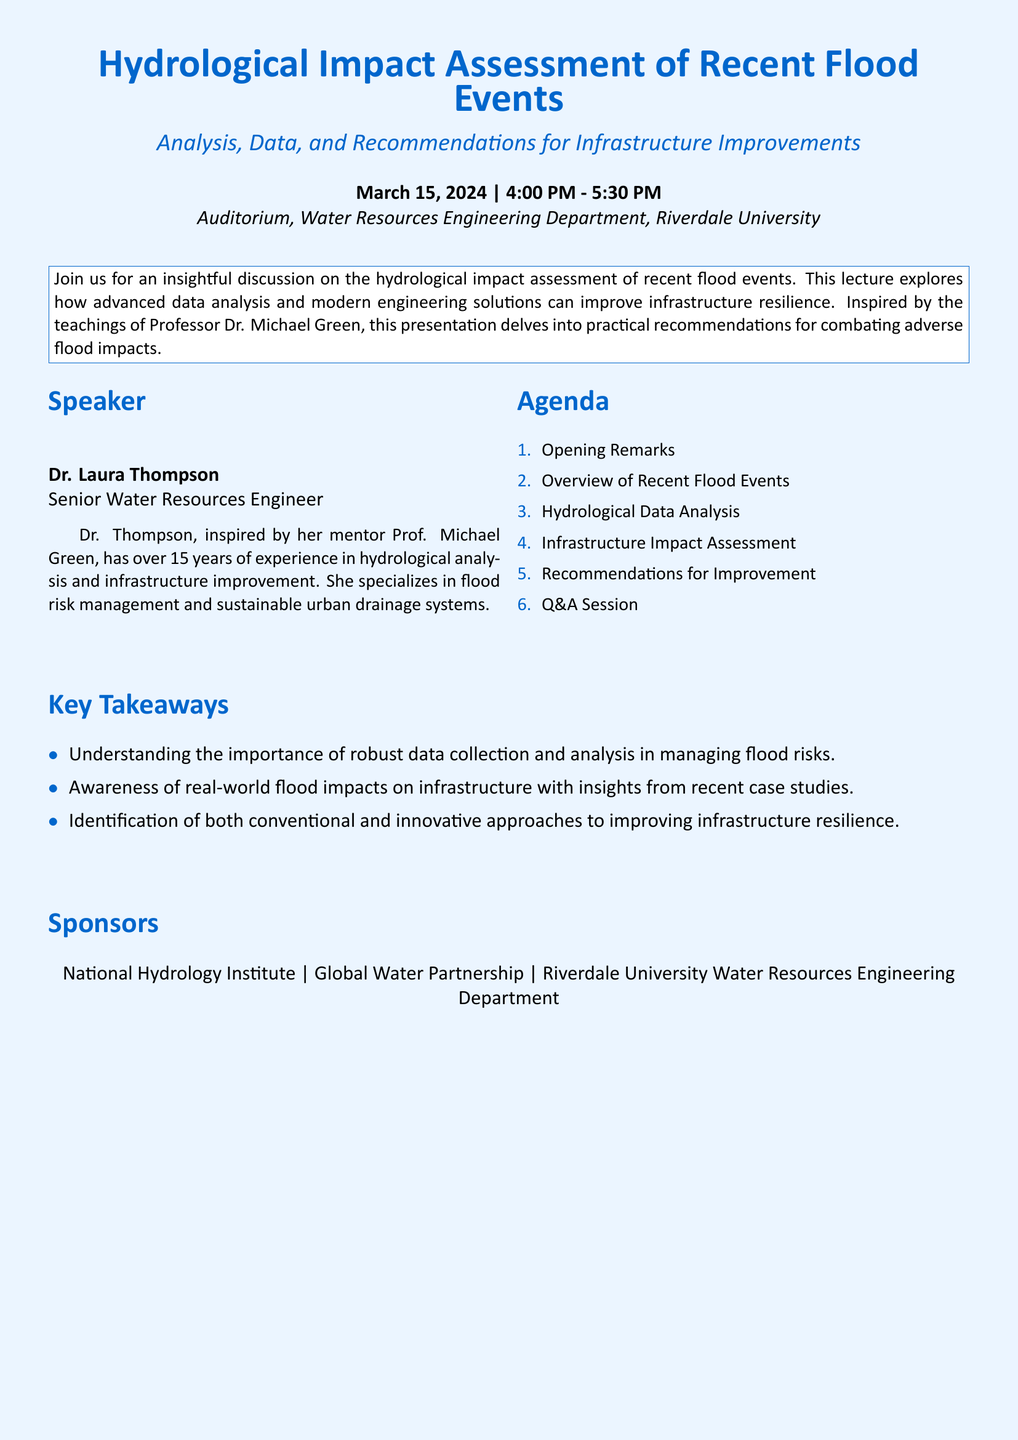What is the title of the event? The title of the event is presented at the top of the document under the name of the playbill.
Answer: Hydrological Impact Assessment of Recent Flood Events Who is the speaker of the event? The speaker's name is listed in the "Speaker" section of the document.
Answer: Dr. Laura Thompson What is the main focus of the lecture? The focus of the lecture is summarized in the description box at the beginning of the document.
Answer: Hydrological impact assessment of recent flood events How many years of experience does Dr. Laura Thompson have? The document states her experience in the speaker's biography.
Answer: 15 years What is one of the key takeaways from the event? Key takeaways are listed in the relevant section of the document.
Answer: Understanding the importance of robust data collection and analysis in managing flood risks What type of audience is this event targeting? The event is organized by the Water Resources Engineering Department and is likely aimed at a professional audience in that field.
Answer: Water resources professionals Who is the mentor that inspired Dr. Laura Thompson? The mentor is mentioned in her speaker biography within the document.
Answer: Prof. Michael Green What kind of session follows the recommendations in the agenda? The agenda specifies the type of session that occurs after recommendations.
Answer: Q&A Session 